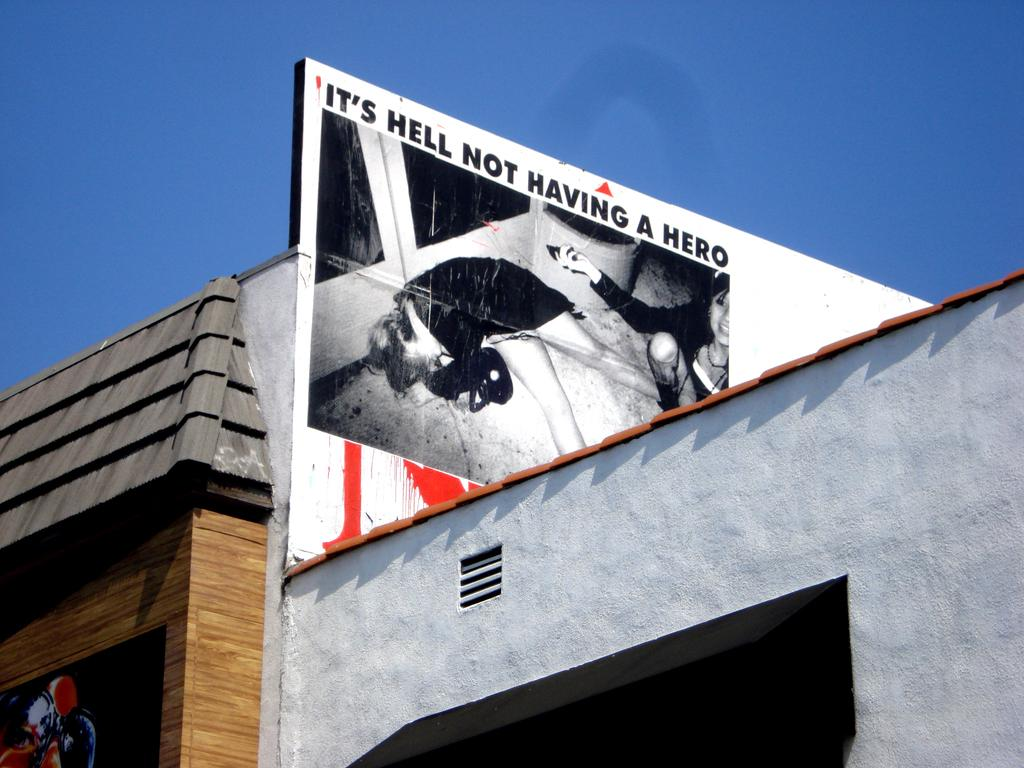What is the main subject of the picture? The main subject of the picture is a building. Are there any additional features on the building? Yes, there are two posters on the walls of the building. What can be seen in the background of the picture? The sky is visible in the background of the picture. How many trees are visible in the room in the image? There is no room present in the image, and therefore no trees can be seen in a room. 